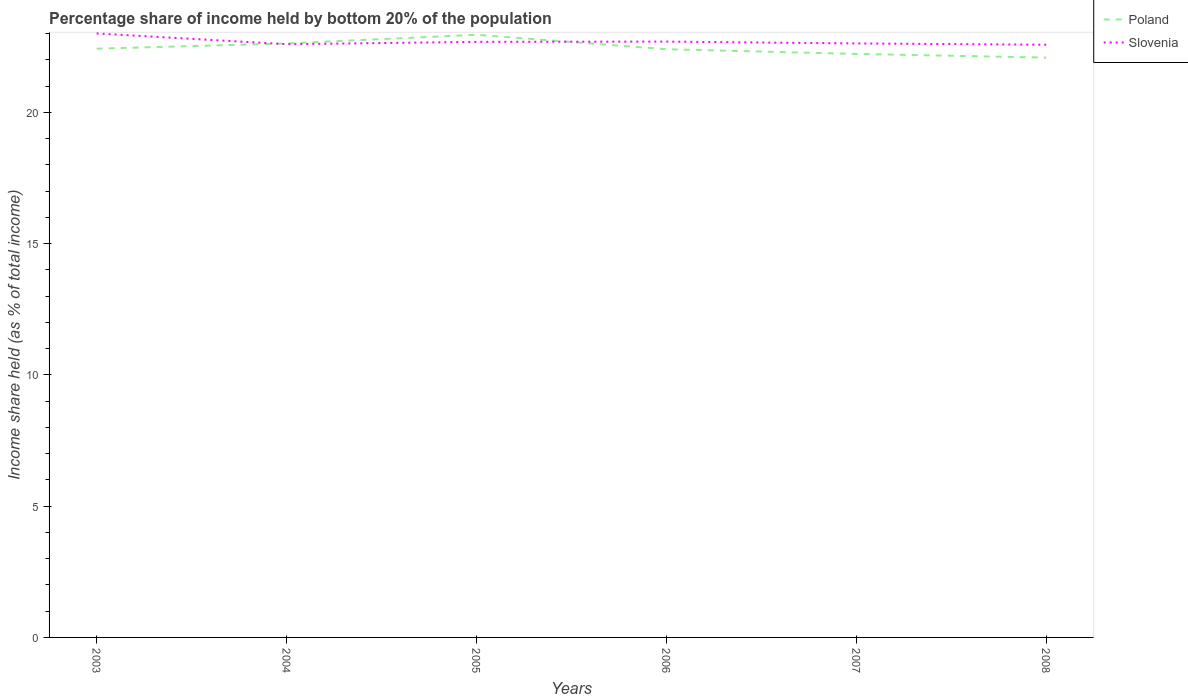Is the number of lines equal to the number of legend labels?
Ensure brevity in your answer.  Yes. Across all years, what is the maximum share of income held by bottom 20% of the population in Slovenia?
Provide a short and direct response. 22.58. What is the total share of income held by bottom 20% of the population in Poland in the graph?
Give a very brief answer. 0.18. What is the difference between the highest and the second highest share of income held by bottom 20% of the population in Slovenia?
Provide a short and direct response. 0.43. Is the share of income held by bottom 20% of the population in Poland strictly greater than the share of income held by bottom 20% of the population in Slovenia over the years?
Your answer should be compact. No. How many lines are there?
Offer a terse response. 2. Where does the legend appear in the graph?
Offer a very short reply. Top right. What is the title of the graph?
Your answer should be very brief. Percentage share of income held by bottom 20% of the population. Does "Sierra Leone" appear as one of the legend labels in the graph?
Offer a terse response. No. What is the label or title of the X-axis?
Give a very brief answer. Years. What is the label or title of the Y-axis?
Your answer should be very brief. Income share held (as % of total income). What is the Income share held (as % of total income) in Poland in 2003?
Offer a very short reply. 22.43. What is the Income share held (as % of total income) of Slovenia in 2003?
Offer a very short reply. 23.01. What is the Income share held (as % of total income) in Poland in 2004?
Offer a very short reply. 22.63. What is the Income share held (as % of total income) of Slovenia in 2004?
Give a very brief answer. 22.6. What is the Income share held (as % of total income) of Poland in 2005?
Provide a short and direct response. 22.96. What is the Income share held (as % of total income) in Slovenia in 2005?
Your answer should be very brief. 22.69. What is the Income share held (as % of total income) in Poland in 2006?
Provide a succinct answer. 22.41. What is the Income share held (as % of total income) in Slovenia in 2006?
Your answer should be very brief. 22.7. What is the Income share held (as % of total income) in Poland in 2007?
Provide a succinct answer. 22.23. What is the Income share held (as % of total income) of Slovenia in 2007?
Provide a succinct answer. 22.63. What is the Income share held (as % of total income) of Poland in 2008?
Your answer should be compact. 22.09. What is the Income share held (as % of total income) of Slovenia in 2008?
Make the answer very short. 22.58. Across all years, what is the maximum Income share held (as % of total income) in Poland?
Ensure brevity in your answer.  22.96. Across all years, what is the maximum Income share held (as % of total income) of Slovenia?
Give a very brief answer. 23.01. Across all years, what is the minimum Income share held (as % of total income) of Poland?
Offer a very short reply. 22.09. Across all years, what is the minimum Income share held (as % of total income) of Slovenia?
Make the answer very short. 22.58. What is the total Income share held (as % of total income) of Poland in the graph?
Offer a very short reply. 134.75. What is the total Income share held (as % of total income) of Slovenia in the graph?
Your answer should be compact. 136.21. What is the difference between the Income share held (as % of total income) of Poland in 2003 and that in 2004?
Ensure brevity in your answer.  -0.2. What is the difference between the Income share held (as % of total income) of Slovenia in 2003 and that in 2004?
Keep it short and to the point. 0.41. What is the difference between the Income share held (as % of total income) in Poland in 2003 and that in 2005?
Give a very brief answer. -0.53. What is the difference between the Income share held (as % of total income) in Slovenia in 2003 and that in 2005?
Provide a short and direct response. 0.32. What is the difference between the Income share held (as % of total income) in Poland in 2003 and that in 2006?
Your answer should be very brief. 0.02. What is the difference between the Income share held (as % of total income) of Slovenia in 2003 and that in 2006?
Your response must be concise. 0.31. What is the difference between the Income share held (as % of total income) in Poland in 2003 and that in 2007?
Your response must be concise. 0.2. What is the difference between the Income share held (as % of total income) in Slovenia in 2003 and that in 2007?
Offer a very short reply. 0.38. What is the difference between the Income share held (as % of total income) in Poland in 2003 and that in 2008?
Offer a terse response. 0.34. What is the difference between the Income share held (as % of total income) of Slovenia in 2003 and that in 2008?
Provide a short and direct response. 0.43. What is the difference between the Income share held (as % of total income) of Poland in 2004 and that in 2005?
Provide a short and direct response. -0.33. What is the difference between the Income share held (as % of total income) in Slovenia in 2004 and that in 2005?
Make the answer very short. -0.09. What is the difference between the Income share held (as % of total income) in Poland in 2004 and that in 2006?
Provide a short and direct response. 0.22. What is the difference between the Income share held (as % of total income) of Slovenia in 2004 and that in 2006?
Ensure brevity in your answer.  -0.1. What is the difference between the Income share held (as % of total income) in Slovenia in 2004 and that in 2007?
Give a very brief answer. -0.03. What is the difference between the Income share held (as % of total income) of Poland in 2004 and that in 2008?
Provide a short and direct response. 0.54. What is the difference between the Income share held (as % of total income) in Poland in 2005 and that in 2006?
Your response must be concise. 0.55. What is the difference between the Income share held (as % of total income) of Slovenia in 2005 and that in 2006?
Make the answer very short. -0.01. What is the difference between the Income share held (as % of total income) of Poland in 2005 and that in 2007?
Make the answer very short. 0.73. What is the difference between the Income share held (as % of total income) in Poland in 2005 and that in 2008?
Give a very brief answer. 0.87. What is the difference between the Income share held (as % of total income) in Slovenia in 2005 and that in 2008?
Your answer should be very brief. 0.11. What is the difference between the Income share held (as % of total income) of Poland in 2006 and that in 2007?
Provide a succinct answer. 0.18. What is the difference between the Income share held (as % of total income) of Slovenia in 2006 and that in 2007?
Your answer should be compact. 0.07. What is the difference between the Income share held (as % of total income) of Poland in 2006 and that in 2008?
Offer a very short reply. 0.32. What is the difference between the Income share held (as % of total income) in Slovenia in 2006 and that in 2008?
Make the answer very short. 0.12. What is the difference between the Income share held (as % of total income) of Poland in 2007 and that in 2008?
Your answer should be very brief. 0.14. What is the difference between the Income share held (as % of total income) in Slovenia in 2007 and that in 2008?
Offer a terse response. 0.05. What is the difference between the Income share held (as % of total income) in Poland in 2003 and the Income share held (as % of total income) in Slovenia in 2004?
Offer a terse response. -0.17. What is the difference between the Income share held (as % of total income) in Poland in 2003 and the Income share held (as % of total income) in Slovenia in 2005?
Offer a very short reply. -0.26. What is the difference between the Income share held (as % of total income) in Poland in 2003 and the Income share held (as % of total income) in Slovenia in 2006?
Give a very brief answer. -0.27. What is the difference between the Income share held (as % of total income) of Poland in 2003 and the Income share held (as % of total income) of Slovenia in 2007?
Provide a short and direct response. -0.2. What is the difference between the Income share held (as % of total income) in Poland in 2004 and the Income share held (as % of total income) in Slovenia in 2005?
Offer a terse response. -0.06. What is the difference between the Income share held (as % of total income) of Poland in 2004 and the Income share held (as % of total income) of Slovenia in 2006?
Make the answer very short. -0.07. What is the difference between the Income share held (as % of total income) in Poland in 2004 and the Income share held (as % of total income) in Slovenia in 2007?
Offer a terse response. 0. What is the difference between the Income share held (as % of total income) of Poland in 2004 and the Income share held (as % of total income) of Slovenia in 2008?
Your response must be concise. 0.05. What is the difference between the Income share held (as % of total income) in Poland in 2005 and the Income share held (as % of total income) in Slovenia in 2006?
Ensure brevity in your answer.  0.26. What is the difference between the Income share held (as % of total income) of Poland in 2005 and the Income share held (as % of total income) of Slovenia in 2007?
Your response must be concise. 0.33. What is the difference between the Income share held (as % of total income) in Poland in 2005 and the Income share held (as % of total income) in Slovenia in 2008?
Keep it short and to the point. 0.38. What is the difference between the Income share held (as % of total income) in Poland in 2006 and the Income share held (as % of total income) in Slovenia in 2007?
Give a very brief answer. -0.22. What is the difference between the Income share held (as % of total income) in Poland in 2006 and the Income share held (as % of total income) in Slovenia in 2008?
Provide a short and direct response. -0.17. What is the difference between the Income share held (as % of total income) of Poland in 2007 and the Income share held (as % of total income) of Slovenia in 2008?
Provide a succinct answer. -0.35. What is the average Income share held (as % of total income) of Poland per year?
Keep it short and to the point. 22.46. What is the average Income share held (as % of total income) of Slovenia per year?
Your answer should be very brief. 22.7. In the year 2003, what is the difference between the Income share held (as % of total income) in Poland and Income share held (as % of total income) in Slovenia?
Your response must be concise. -0.58. In the year 2005, what is the difference between the Income share held (as % of total income) of Poland and Income share held (as % of total income) of Slovenia?
Your answer should be compact. 0.27. In the year 2006, what is the difference between the Income share held (as % of total income) of Poland and Income share held (as % of total income) of Slovenia?
Your response must be concise. -0.29. In the year 2007, what is the difference between the Income share held (as % of total income) in Poland and Income share held (as % of total income) in Slovenia?
Offer a very short reply. -0.4. In the year 2008, what is the difference between the Income share held (as % of total income) of Poland and Income share held (as % of total income) of Slovenia?
Offer a very short reply. -0.49. What is the ratio of the Income share held (as % of total income) in Poland in 2003 to that in 2004?
Keep it short and to the point. 0.99. What is the ratio of the Income share held (as % of total income) in Slovenia in 2003 to that in 2004?
Offer a very short reply. 1.02. What is the ratio of the Income share held (as % of total income) of Poland in 2003 to that in 2005?
Your response must be concise. 0.98. What is the ratio of the Income share held (as % of total income) in Slovenia in 2003 to that in 2005?
Your response must be concise. 1.01. What is the ratio of the Income share held (as % of total income) in Poland in 2003 to that in 2006?
Your answer should be compact. 1. What is the ratio of the Income share held (as % of total income) in Slovenia in 2003 to that in 2006?
Offer a very short reply. 1.01. What is the ratio of the Income share held (as % of total income) in Slovenia in 2003 to that in 2007?
Ensure brevity in your answer.  1.02. What is the ratio of the Income share held (as % of total income) of Poland in 2003 to that in 2008?
Your answer should be compact. 1.02. What is the ratio of the Income share held (as % of total income) in Poland in 2004 to that in 2005?
Your response must be concise. 0.99. What is the ratio of the Income share held (as % of total income) in Poland in 2004 to that in 2006?
Keep it short and to the point. 1.01. What is the ratio of the Income share held (as % of total income) of Slovenia in 2004 to that in 2006?
Ensure brevity in your answer.  1. What is the ratio of the Income share held (as % of total income) in Poland in 2004 to that in 2007?
Provide a short and direct response. 1.02. What is the ratio of the Income share held (as % of total income) of Slovenia in 2004 to that in 2007?
Give a very brief answer. 1. What is the ratio of the Income share held (as % of total income) of Poland in 2004 to that in 2008?
Keep it short and to the point. 1.02. What is the ratio of the Income share held (as % of total income) of Slovenia in 2004 to that in 2008?
Your response must be concise. 1. What is the ratio of the Income share held (as % of total income) in Poland in 2005 to that in 2006?
Your response must be concise. 1.02. What is the ratio of the Income share held (as % of total income) of Slovenia in 2005 to that in 2006?
Provide a short and direct response. 1. What is the ratio of the Income share held (as % of total income) in Poland in 2005 to that in 2007?
Your response must be concise. 1.03. What is the ratio of the Income share held (as % of total income) in Poland in 2005 to that in 2008?
Provide a short and direct response. 1.04. What is the ratio of the Income share held (as % of total income) in Slovenia in 2005 to that in 2008?
Make the answer very short. 1. What is the ratio of the Income share held (as % of total income) in Poland in 2006 to that in 2008?
Ensure brevity in your answer.  1.01. What is the ratio of the Income share held (as % of total income) in Slovenia in 2006 to that in 2008?
Provide a short and direct response. 1.01. What is the ratio of the Income share held (as % of total income) of Poland in 2007 to that in 2008?
Your answer should be compact. 1.01. What is the difference between the highest and the second highest Income share held (as % of total income) in Poland?
Give a very brief answer. 0.33. What is the difference between the highest and the second highest Income share held (as % of total income) of Slovenia?
Your answer should be compact. 0.31. What is the difference between the highest and the lowest Income share held (as % of total income) in Poland?
Your response must be concise. 0.87. What is the difference between the highest and the lowest Income share held (as % of total income) of Slovenia?
Keep it short and to the point. 0.43. 